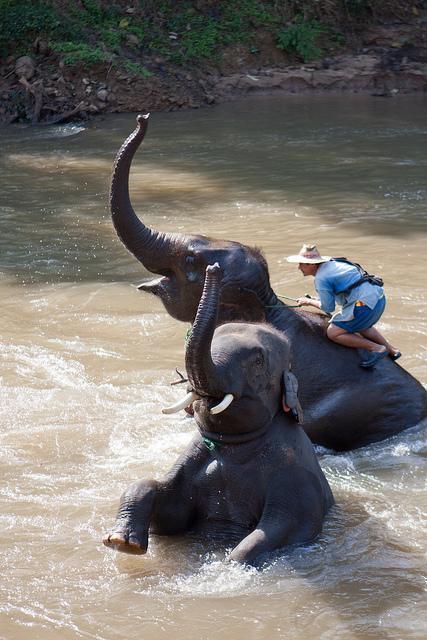How many elephants are there?
Give a very brief answer. 2. How many elephants are in the photo?
Give a very brief answer. 2. How many bottles are on the counter?
Give a very brief answer. 0. 